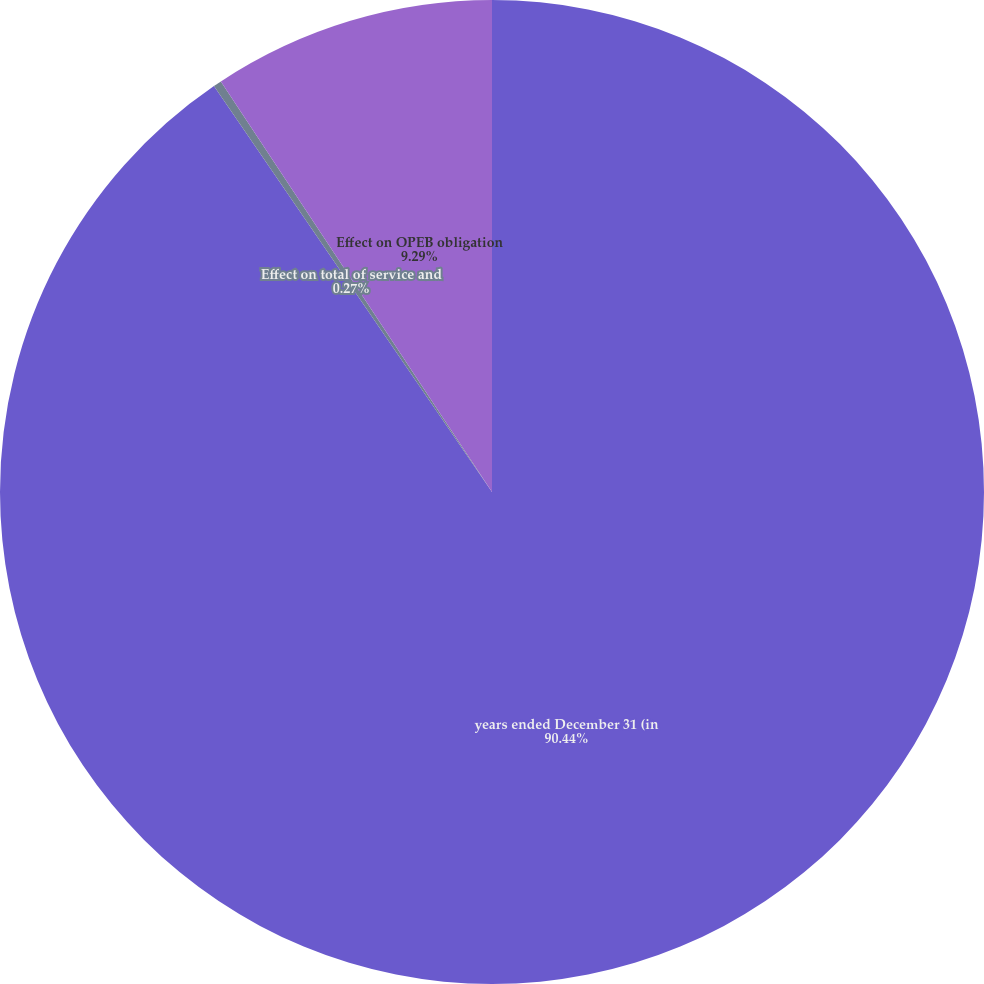Convert chart. <chart><loc_0><loc_0><loc_500><loc_500><pie_chart><fcel>years ended December 31 (in<fcel>Effect on total of service and<fcel>Effect on OPEB obligation<nl><fcel>90.44%<fcel>0.27%<fcel>9.29%<nl></chart> 